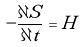<formula> <loc_0><loc_0><loc_500><loc_500>- \frac { \partial S } { \partial t } = H</formula> 